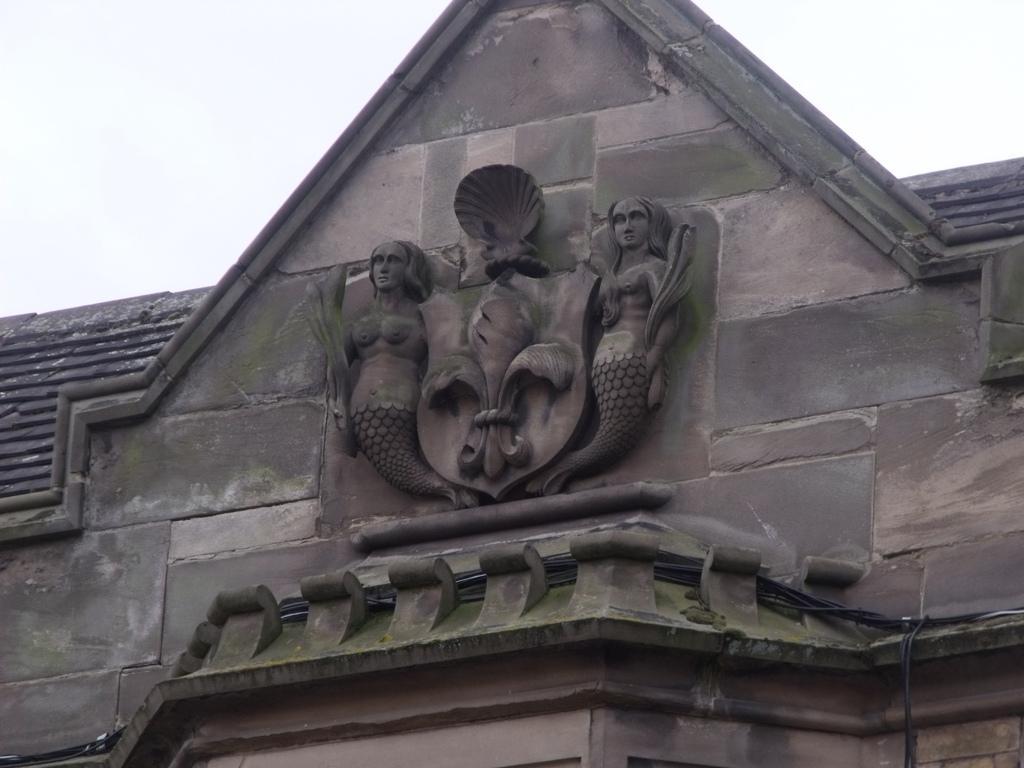Could you give a brief overview of what you see in this image? In the picture we can see a historical building with an upper part with mermaid structures to it and in the middle of it, we can see some design and behind the building we can see a sky. 